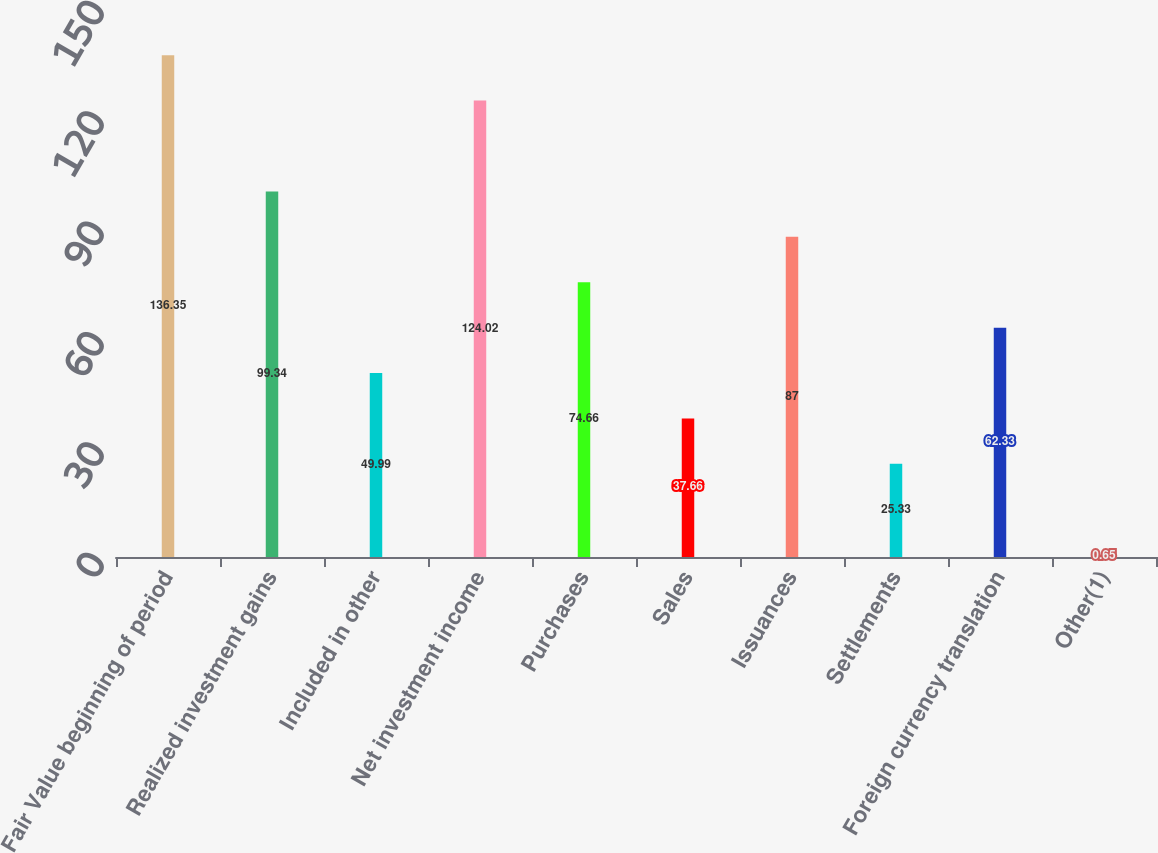Convert chart to OTSL. <chart><loc_0><loc_0><loc_500><loc_500><bar_chart><fcel>Fair Value beginning of period<fcel>Realized investment gains<fcel>Included in other<fcel>Net investment income<fcel>Purchases<fcel>Sales<fcel>Issuances<fcel>Settlements<fcel>Foreign currency translation<fcel>Other(1)<nl><fcel>136.35<fcel>99.34<fcel>49.99<fcel>124.02<fcel>74.66<fcel>37.66<fcel>87<fcel>25.33<fcel>62.33<fcel>0.65<nl></chart> 